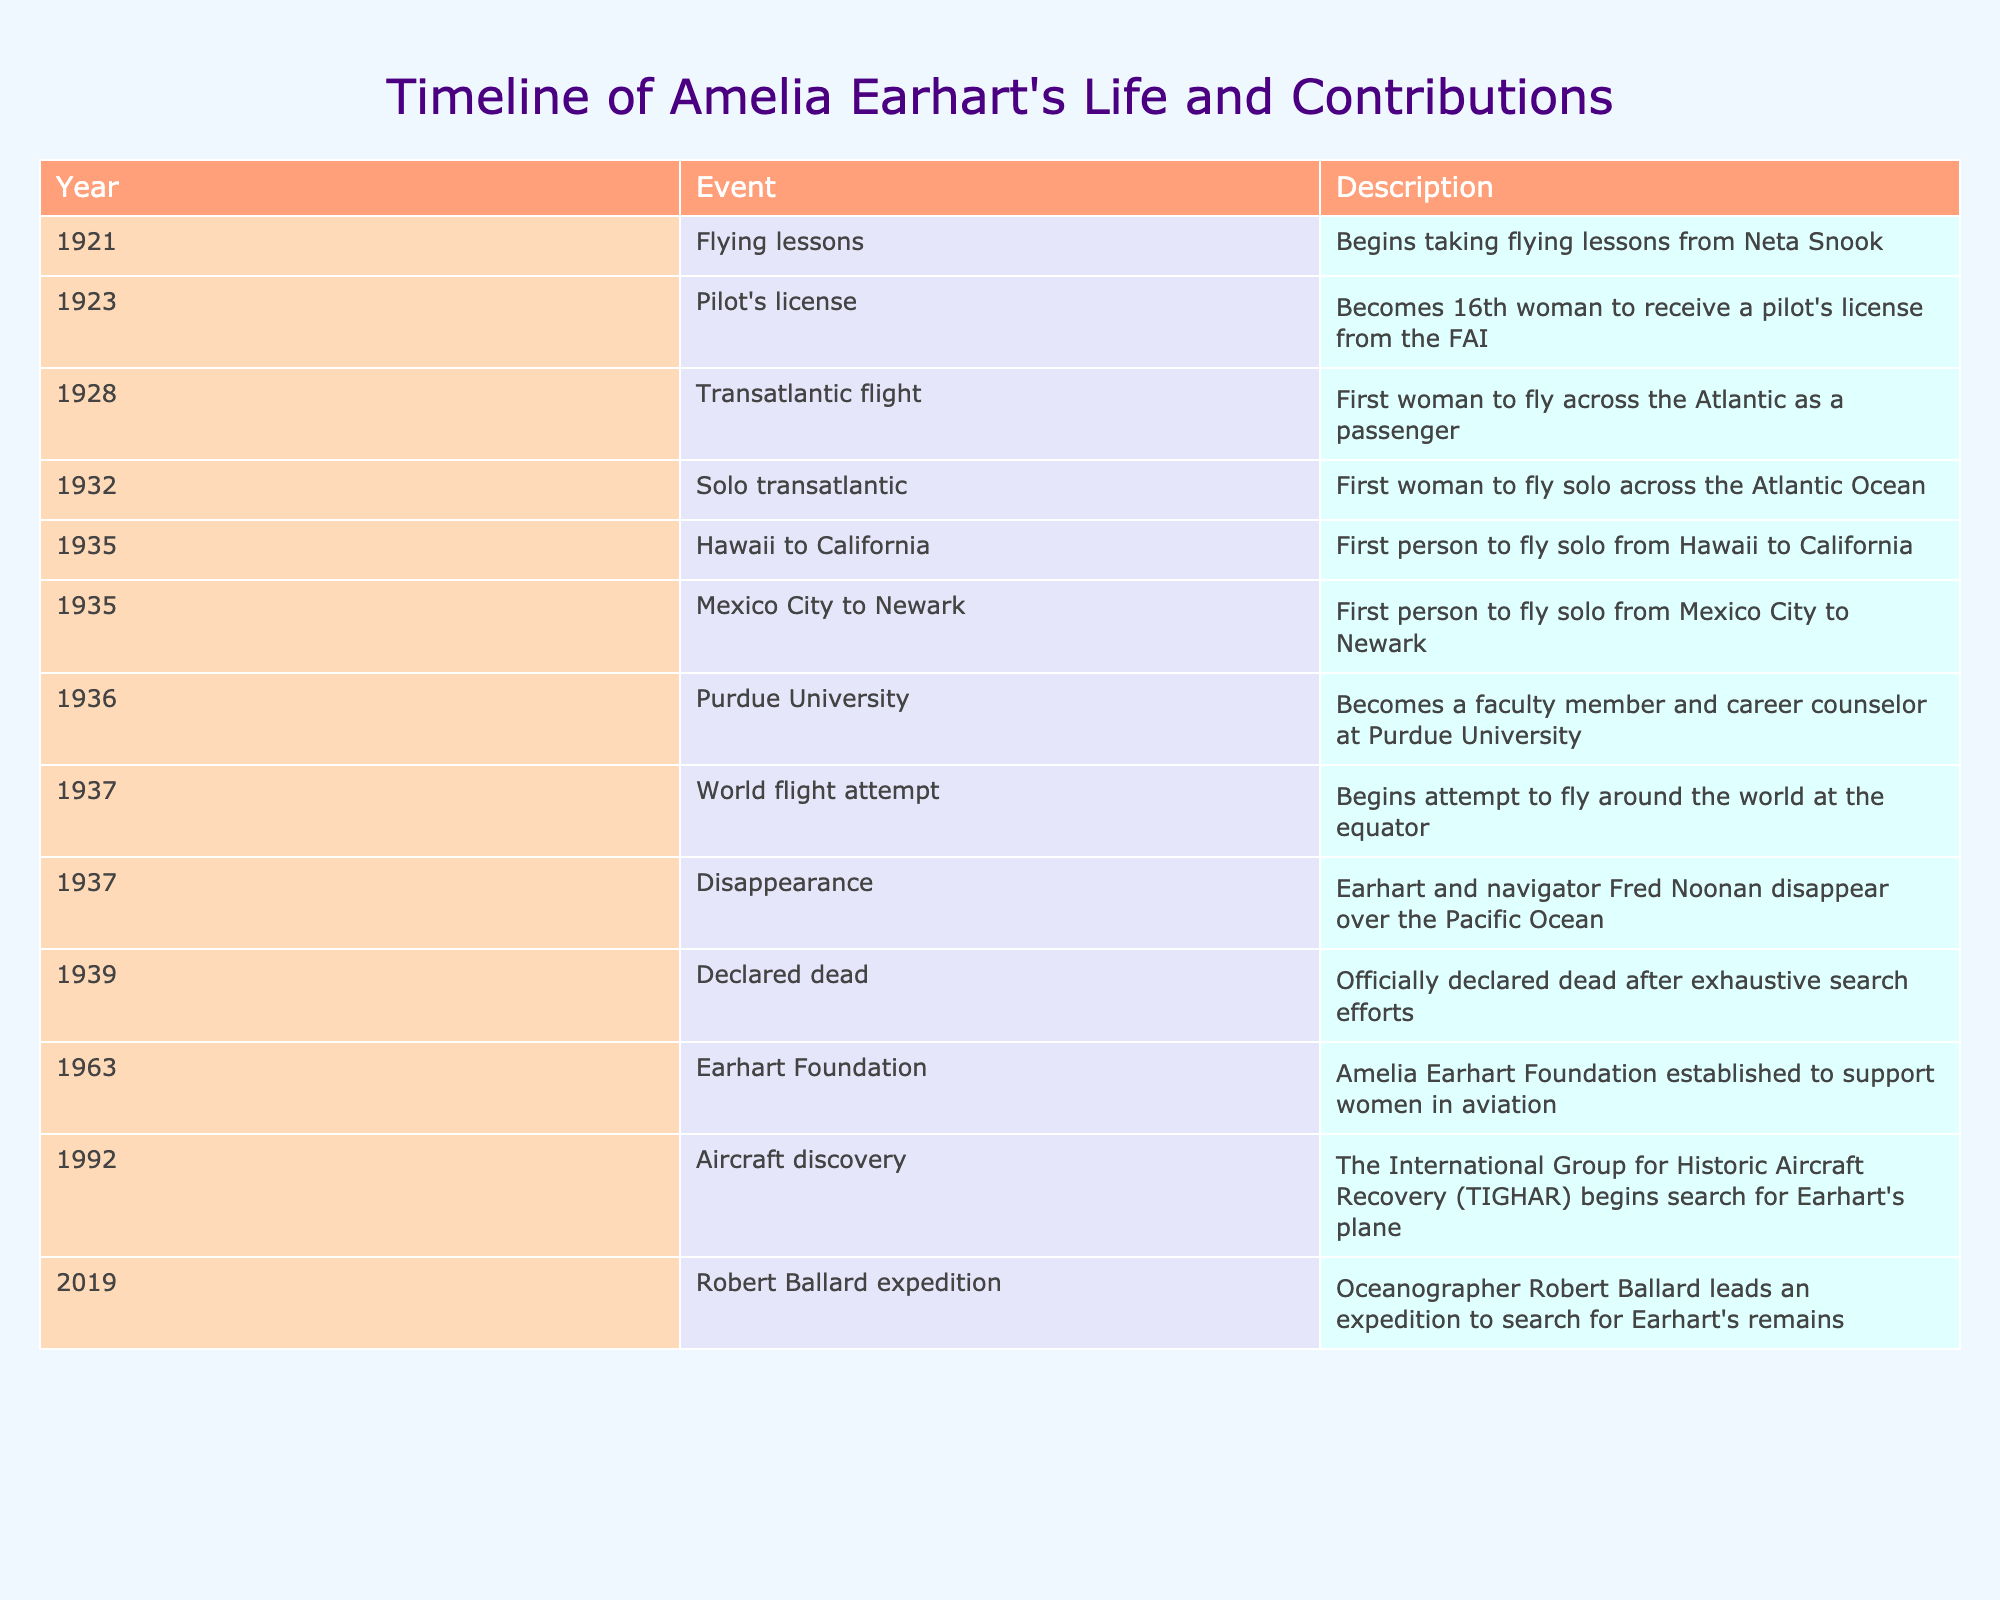What year did Amelia Earhart begin taking flying lessons? According to the table, Amelia Earhart began taking flying lessons in 1921, as listed in the first row of the timeline.
Answer: 1921 How many significant events in Earhart's life occurred in 1935? Two events related to Amelia Earhart occurred in 1935: she was the first person to fly solo from Hawaii to California and the first person to fly solo from Mexico City to Newark. This can be found by checking the events listed under the year 1935 in the table.
Answer: 2 Was Amelia Earhart the first woman to receive a pilot's license? No, Amelia Earhart was not the first woman to receive a pilot's license; she was the 16th woman to do so, as indicated in the 1923 row of the timeline.
Answer: No What year did Amelia Earhart attempt to fly around the world? Earhart began her attempt to fly around the world in 1937, as stated in the table under that year.
Answer: 1937 How many years were there between Amelia Earhart's transatlantic solo flight and her disappearance? Earhart flew solo across the Atlantic Ocean in 1932 and disappeared in 1937. The difference between these years is 1937 - 1932 = 5 years. Therefore, there were five years between these two significant events.
Answer: 5 Which event occurred first, her being declared dead or the establishment of the Earhart Foundation? The table indicates that she was declared dead in 1939 and the Earhart Foundation was established in 1963. Therefore, the event of her declaration of death occurred first.
Answer: Declaration of death How many total years did it take from Amelia Earhart obtaining her pilot's license to her disappearance? Earhart received her pilot's license in 1923 and disappeared in 1937. The time span is calculated as 1937 - 1923 = 14 years. Thus, it took 14 years from obtaining her license to her disappearance.
Answer: 14 Did Amelia Earhart complete her round-the-world flight attempt? No, Amelia Earhart did not complete her round-the-world flight attempt as she disappeared during the attempt in 1937. This is clearly stated in the timeline.
Answer: No 